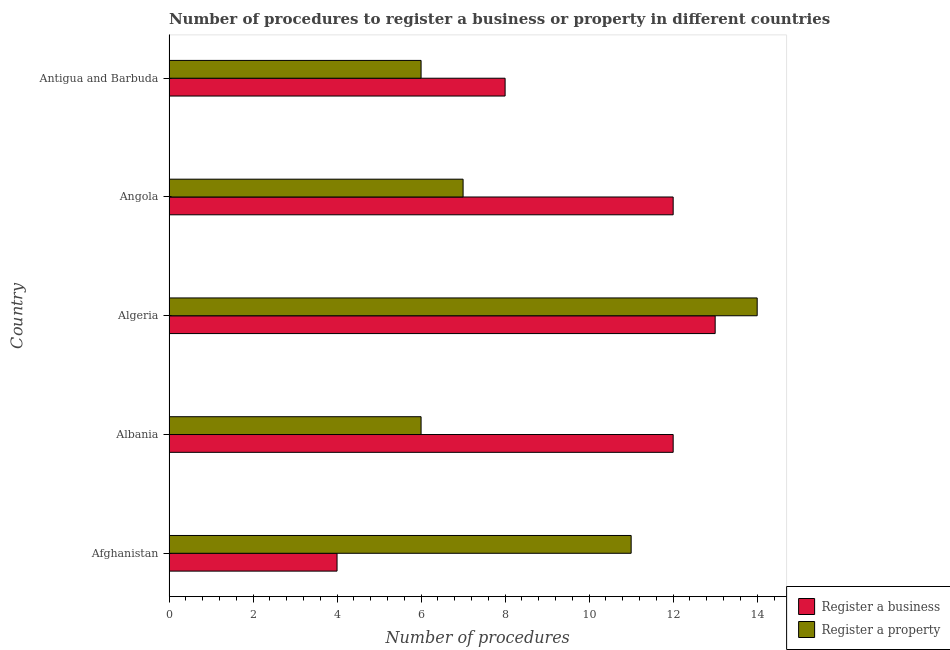How many different coloured bars are there?
Provide a short and direct response. 2. How many groups of bars are there?
Your answer should be compact. 5. Are the number of bars per tick equal to the number of legend labels?
Ensure brevity in your answer.  Yes. How many bars are there on the 2nd tick from the top?
Provide a short and direct response. 2. How many bars are there on the 4th tick from the bottom?
Keep it short and to the point. 2. What is the label of the 2nd group of bars from the top?
Your response must be concise. Angola. In how many cases, is the number of bars for a given country not equal to the number of legend labels?
Make the answer very short. 0. What is the number of procedures to register a business in Afghanistan?
Your response must be concise. 4. In which country was the number of procedures to register a property maximum?
Your answer should be compact. Algeria. In which country was the number of procedures to register a business minimum?
Provide a succinct answer. Afghanistan. What is the total number of procedures to register a business in the graph?
Make the answer very short. 49. What is the average number of procedures to register a property per country?
Your response must be concise. 8.8. In how many countries, is the number of procedures to register a property greater than 9.6 ?
Make the answer very short. 2. What is the ratio of the number of procedures to register a business in Albania to that in Angola?
Give a very brief answer. 1. Is the difference between the number of procedures to register a business in Afghanistan and Algeria greater than the difference between the number of procedures to register a property in Afghanistan and Algeria?
Make the answer very short. No. What is the difference between the highest and the lowest number of procedures to register a property?
Your response must be concise. 8. In how many countries, is the number of procedures to register a property greater than the average number of procedures to register a property taken over all countries?
Offer a terse response. 2. What does the 1st bar from the top in Albania represents?
Offer a very short reply. Register a property. What does the 1st bar from the bottom in Albania represents?
Provide a short and direct response. Register a business. How many bars are there?
Your answer should be compact. 10. Are all the bars in the graph horizontal?
Your response must be concise. Yes. How many countries are there in the graph?
Offer a terse response. 5. Are the values on the major ticks of X-axis written in scientific E-notation?
Your answer should be very brief. No. Does the graph contain any zero values?
Ensure brevity in your answer.  No. Does the graph contain grids?
Keep it short and to the point. No. What is the title of the graph?
Offer a terse response. Number of procedures to register a business or property in different countries. Does "Goods" appear as one of the legend labels in the graph?
Your response must be concise. No. What is the label or title of the X-axis?
Your response must be concise. Number of procedures. What is the label or title of the Y-axis?
Your answer should be compact. Country. What is the Number of procedures in Register a business in Afghanistan?
Your answer should be very brief. 4. What is the Number of procedures of Register a business in Albania?
Provide a short and direct response. 12. What is the Number of procedures of Register a business in Algeria?
Give a very brief answer. 13. What is the Number of procedures in Register a property in Algeria?
Keep it short and to the point. 14. What is the Number of procedures in Register a business in Angola?
Provide a succinct answer. 12. What is the Number of procedures of Register a property in Angola?
Provide a succinct answer. 7. What is the Number of procedures in Register a property in Antigua and Barbuda?
Make the answer very short. 6. Across all countries, what is the maximum Number of procedures in Register a property?
Your answer should be compact. 14. Across all countries, what is the minimum Number of procedures in Register a property?
Provide a short and direct response. 6. What is the total Number of procedures in Register a property in the graph?
Your answer should be very brief. 44. What is the difference between the Number of procedures in Register a business in Afghanistan and that in Algeria?
Your answer should be very brief. -9. What is the difference between the Number of procedures of Register a property in Afghanistan and that in Algeria?
Your answer should be compact. -3. What is the difference between the Number of procedures of Register a business in Afghanistan and that in Angola?
Your response must be concise. -8. What is the difference between the Number of procedures of Register a property in Afghanistan and that in Angola?
Offer a terse response. 4. What is the difference between the Number of procedures of Register a business in Afghanistan and that in Antigua and Barbuda?
Keep it short and to the point. -4. What is the difference between the Number of procedures of Register a property in Afghanistan and that in Antigua and Barbuda?
Provide a succinct answer. 5. What is the difference between the Number of procedures of Register a business in Albania and that in Angola?
Make the answer very short. 0. What is the difference between the Number of procedures of Register a business in Algeria and that in Antigua and Barbuda?
Your answer should be compact. 5. What is the difference between the Number of procedures of Register a business in Angola and that in Antigua and Barbuda?
Offer a terse response. 4. What is the difference between the Number of procedures of Register a property in Angola and that in Antigua and Barbuda?
Give a very brief answer. 1. What is the difference between the Number of procedures in Register a business in Afghanistan and the Number of procedures in Register a property in Algeria?
Offer a very short reply. -10. What is the difference between the Number of procedures of Register a business in Afghanistan and the Number of procedures of Register a property in Angola?
Provide a short and direct response. -3. What is the difference between the Number of procedures in Register a business in Albania and the Number of procedures in Register a property in Algeria?
Your answer should be compact. -2. What is the difference between the Number of procedures of Register a business in Algeria and the Number of procedures of Register a property in Angola?
Keep it short and to the point. 6. What is the difference between the Number of procedures of Register a business in Angola and the Number of procedures of Register a property in Antigua and Barbuda?
Provide a short and direct response. 6. What is the average Number of procedures in Register a business per country?
Offer a terse response. 9.8. What is the difference between the Number of procedures in Register a business and Number of procedures in Register a property in Afghanistan?
Your answer should be compact. -7. What is the difference between the Number of procedures of Register a business and Number of procedures of Register a property in Albania?
Make the answer very short. 6. What is the ratio of the Number of procedures in Register a property in Afghanistan to that in Albania?
Your answer should be very brief. 1.83. What is the ratio of the Number of procedures of Register a business in Afghanistan to that in Algeria?
Keep it short and to the point. 0.31. What is the ratio of the Number of procedures of Register a property in Afghanistan to that in Algeria?
Offer a terse response. 0.79. What is the ratio of the Number of procedures in Register a business in Afghanistan to that in Angola?
Your response must be concise. 0.33. What is the ratio of the Number of procedures in Register a property in Afghanistan to that in Angola?
Your response must be concise. 1.57. What is the ratio of the Number of procedures in Register a property in Afghanistan to that in Antigua and Barbuda?
Your answer should be very brief. 1.83. What is the ratio of the Number of procedures in Register a property in Albania to that in Algeria?
Keep it short and to the point. 0.43. What is the ratio of the Number of procedures in Register a business in Albania to that in Angola?
Offer a terse response. 1. What is the ratio of the Number of procedures of Register a business in Albania to that in Antigua and Barbuda?
Your answer should be compact. 1.5. What is the ratio of the Number of procedures in Register a property in Albania to that in Antigua and Barbuda?
Your response must be concise. 1. What is the ratio of the Number of procedures of Register a business in Algeria to that in Antigua and Barbuda?
Make the answer very short. 1.62. What is the ratio of the Number of procedures in Register a property in Algeria to that in Antigua and Barbuda?
Provide a succinct answer. 2.33. What is the ratio of the Number of procedures of Register a property in Angola to that in Antigua and Barbuda?
Give a very brief answer. 1.17. What is the difference between the highest and the second highest Number of procedures of Register a property?
Your response must be concise. 3. What is the difference between the highest and the lowest Number of procedures of Register a property?
Offer a terse response. 8. 